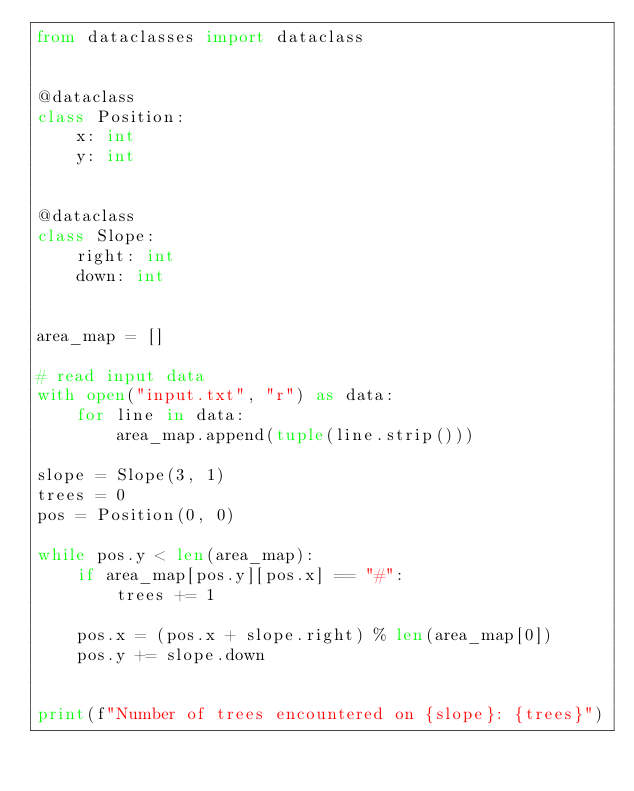<code> <loc_0><loc_0><loc_500><loc_500><_Python_>from dataclasses import dataclass


@dataclass
class Position:
    x: int
    y: int


@dataclass
class Slope:
    right: int
    down: int


area_map = []

# read input data
with open("input.txt", "r") as data:
    for line in data:
        area_map.append(tuple(line.strip()))

slope = Slope(3, 1)
trees = 0
pos = Position(0, 0)

while pos.y < len(area_map):
    if area_map[pos.y][pos.x] == "#":
        trees += 1

    pos.x = (pos.x + slope.right) % len(area_map[0])
    pos.y += slope.down


print(f"Number of trees encountered on {slope}: {trees}")
</code> 